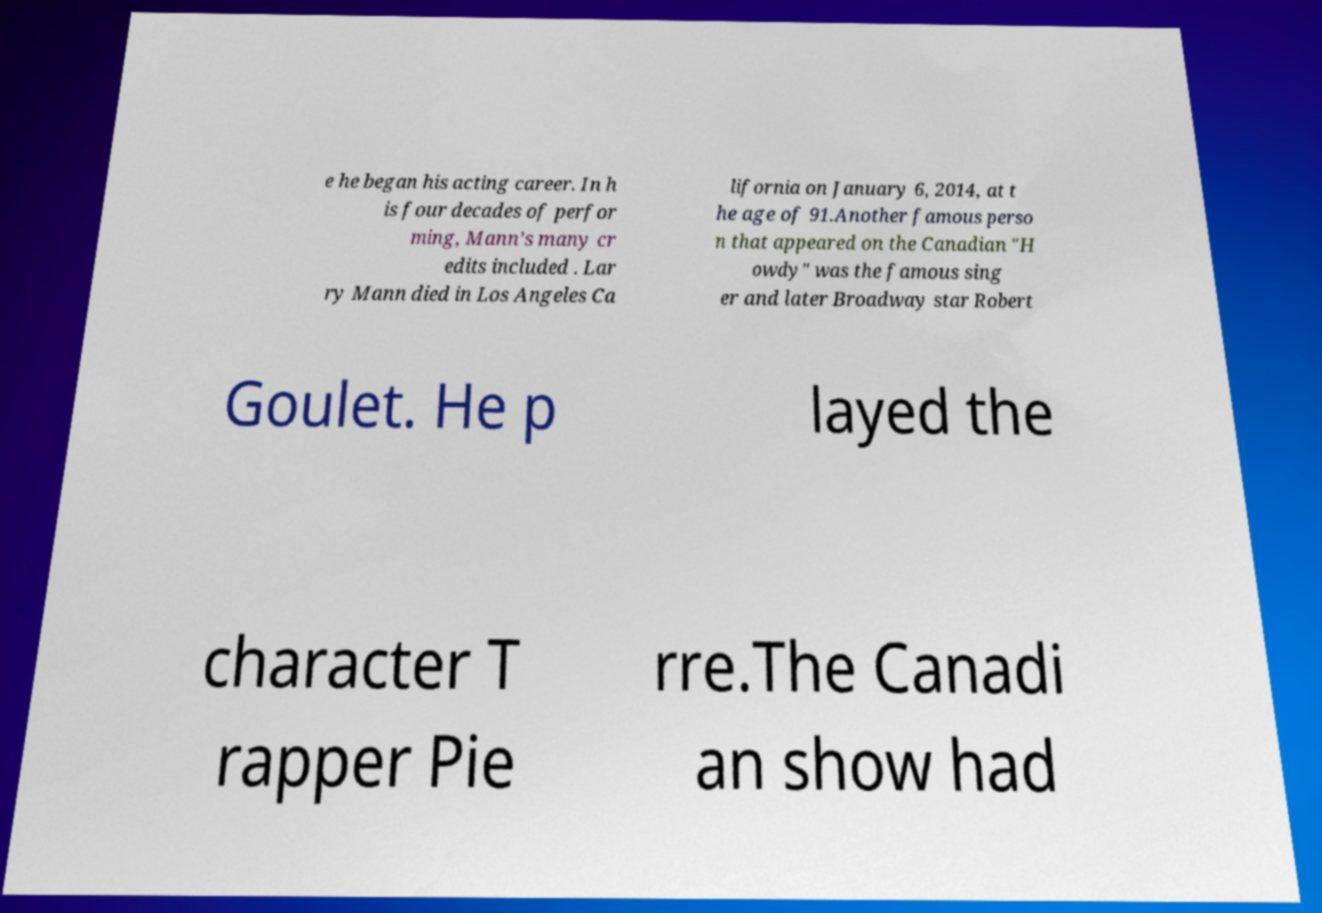Can you accurately transcribe the text from the provided image for me? e he began his acting career. In h is four decades of perfor ming, Mann’s many cr edits included . Lar ry Mann died in Los Angeles Ca lifornia on January 6, 2014, at t he age of 91.Another famous perso n that appeared on the Canadian "H owdy" was the famous sing er and later Broadway star Robert Goulet. He p layed the character T rapper Pie rre.The Canadi an show had 